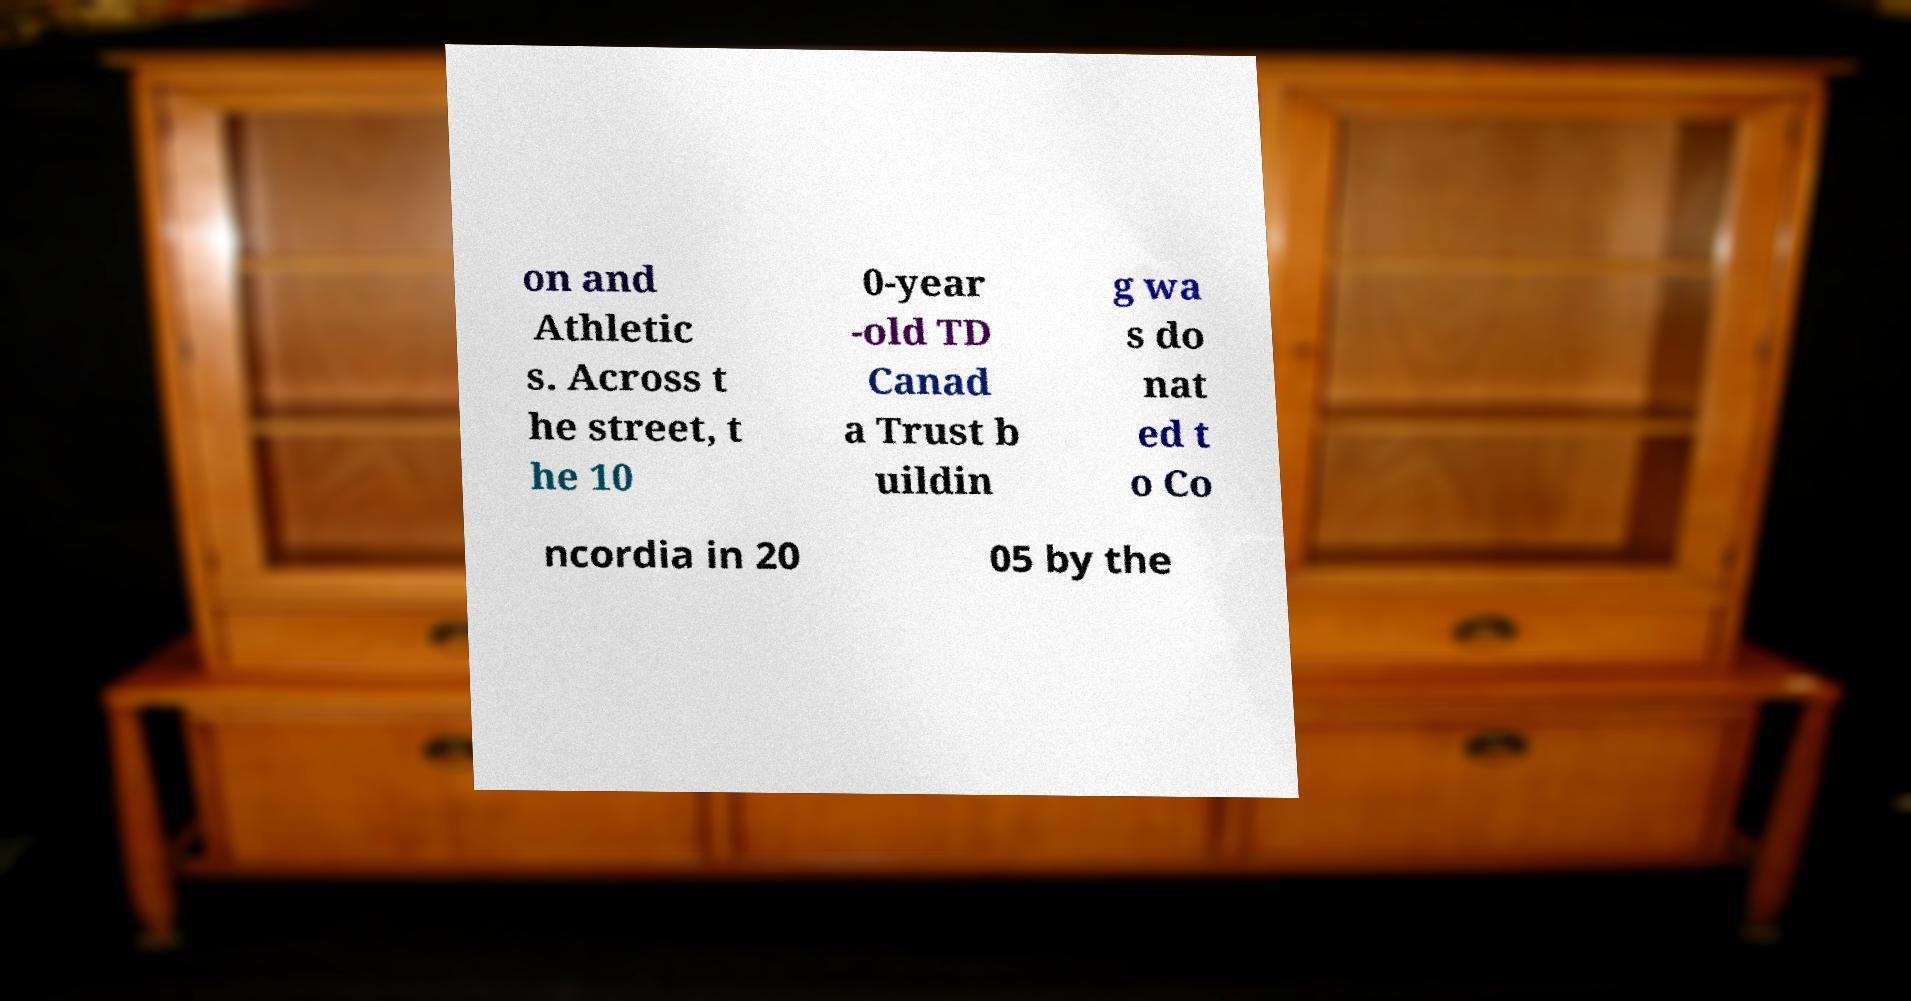Please identify and transcribe the text found in this image. on and Athletic s. Across t he street, t he 10 0-year -old TD Canad a Trust b uildin g wa s do nat ed t o Co ncordia in 20 05 by the 